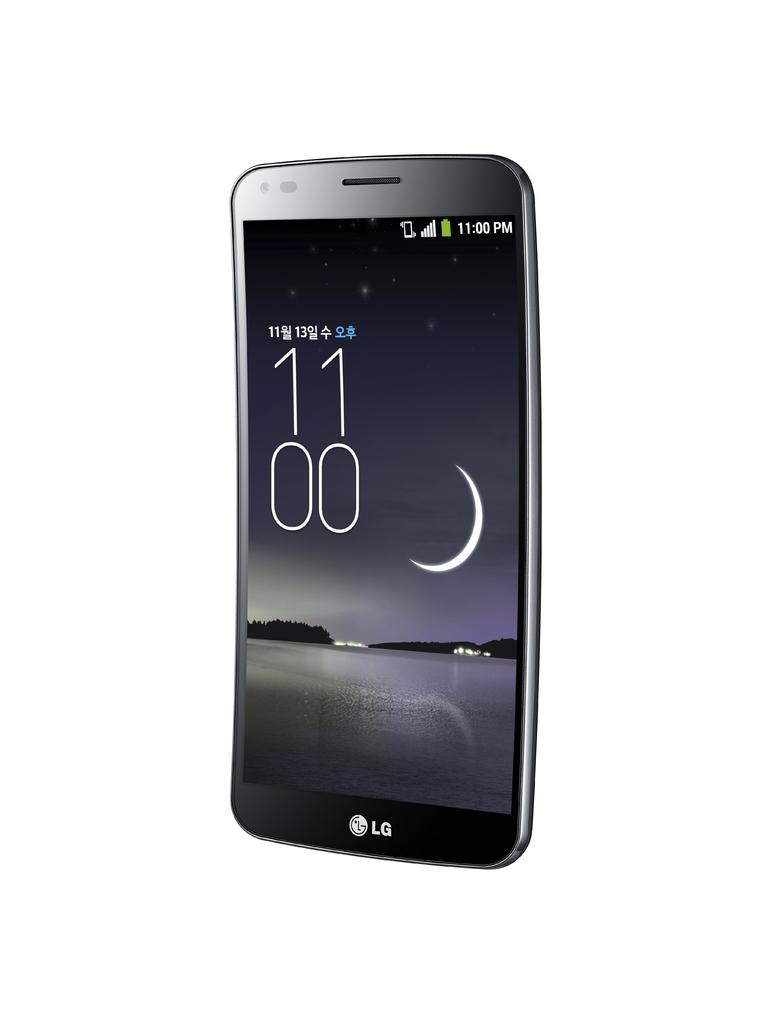<image>
Provide a brief description of the given image. a phone that has the time of 1100 on it 